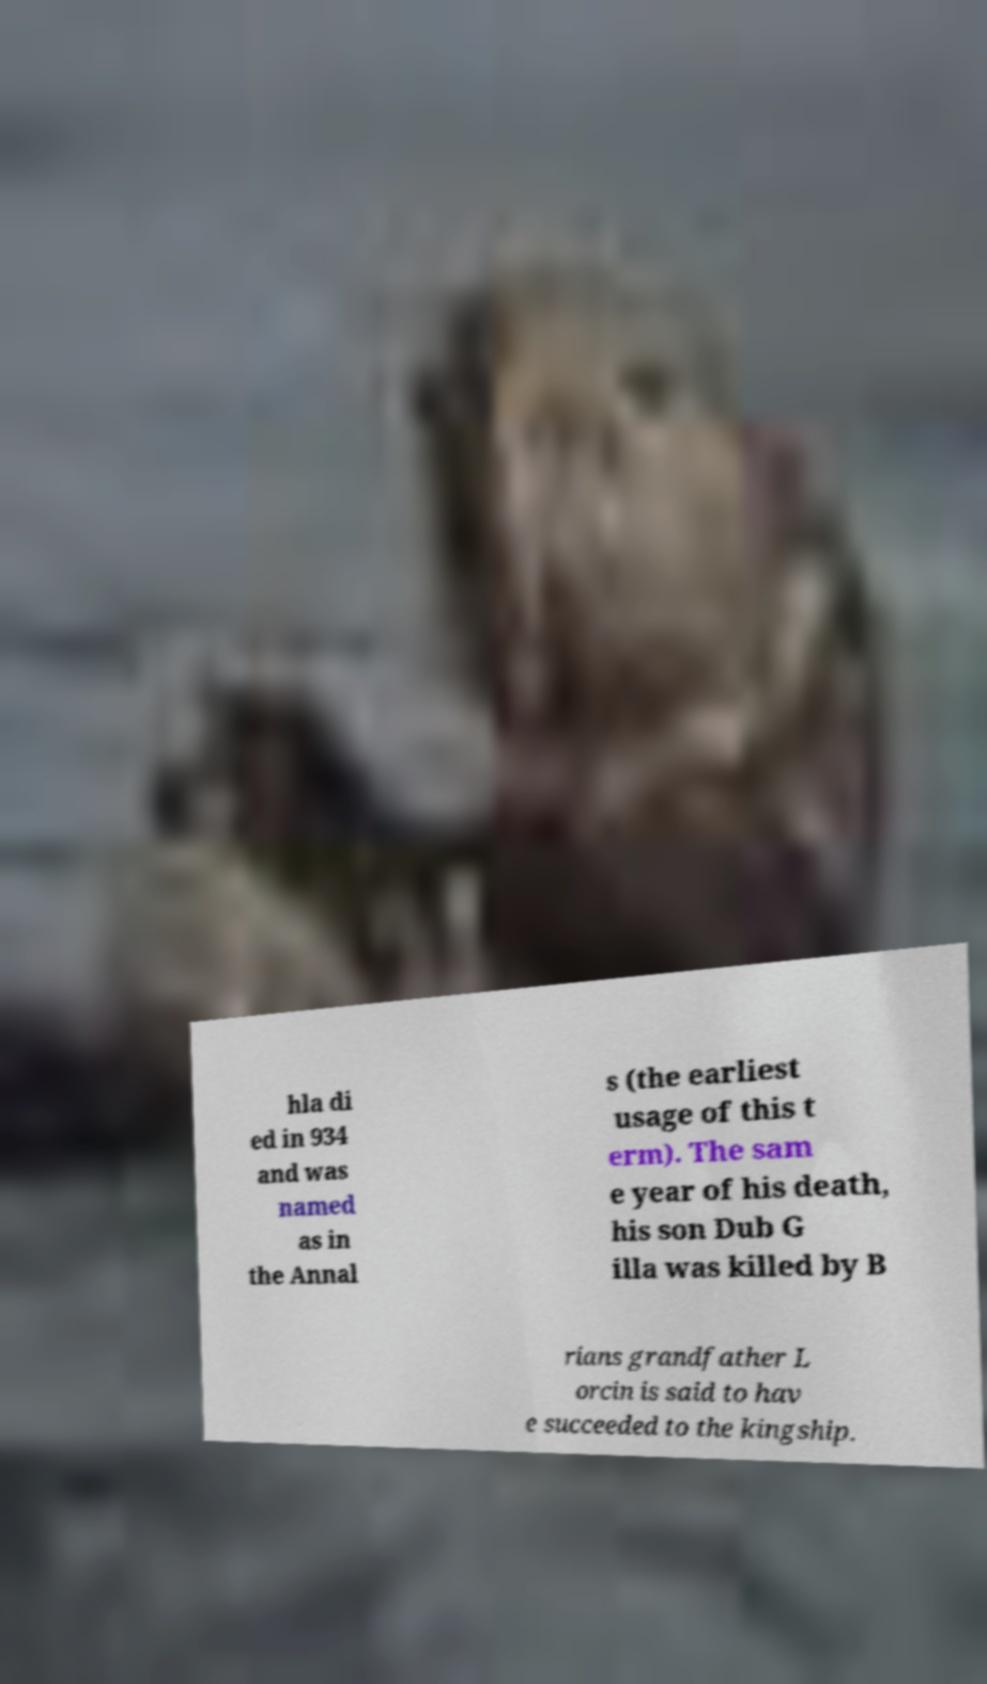What messages or text are displayed in this image? I need them in a readable, typed format. hla di ed in 934 and was named as in the Annal s (the earliest usage of this t erm). The sam e year of his death, his son Dub G illa was killed by B rians grandfather L orcin is said to hav e succeeded to the kingship. 